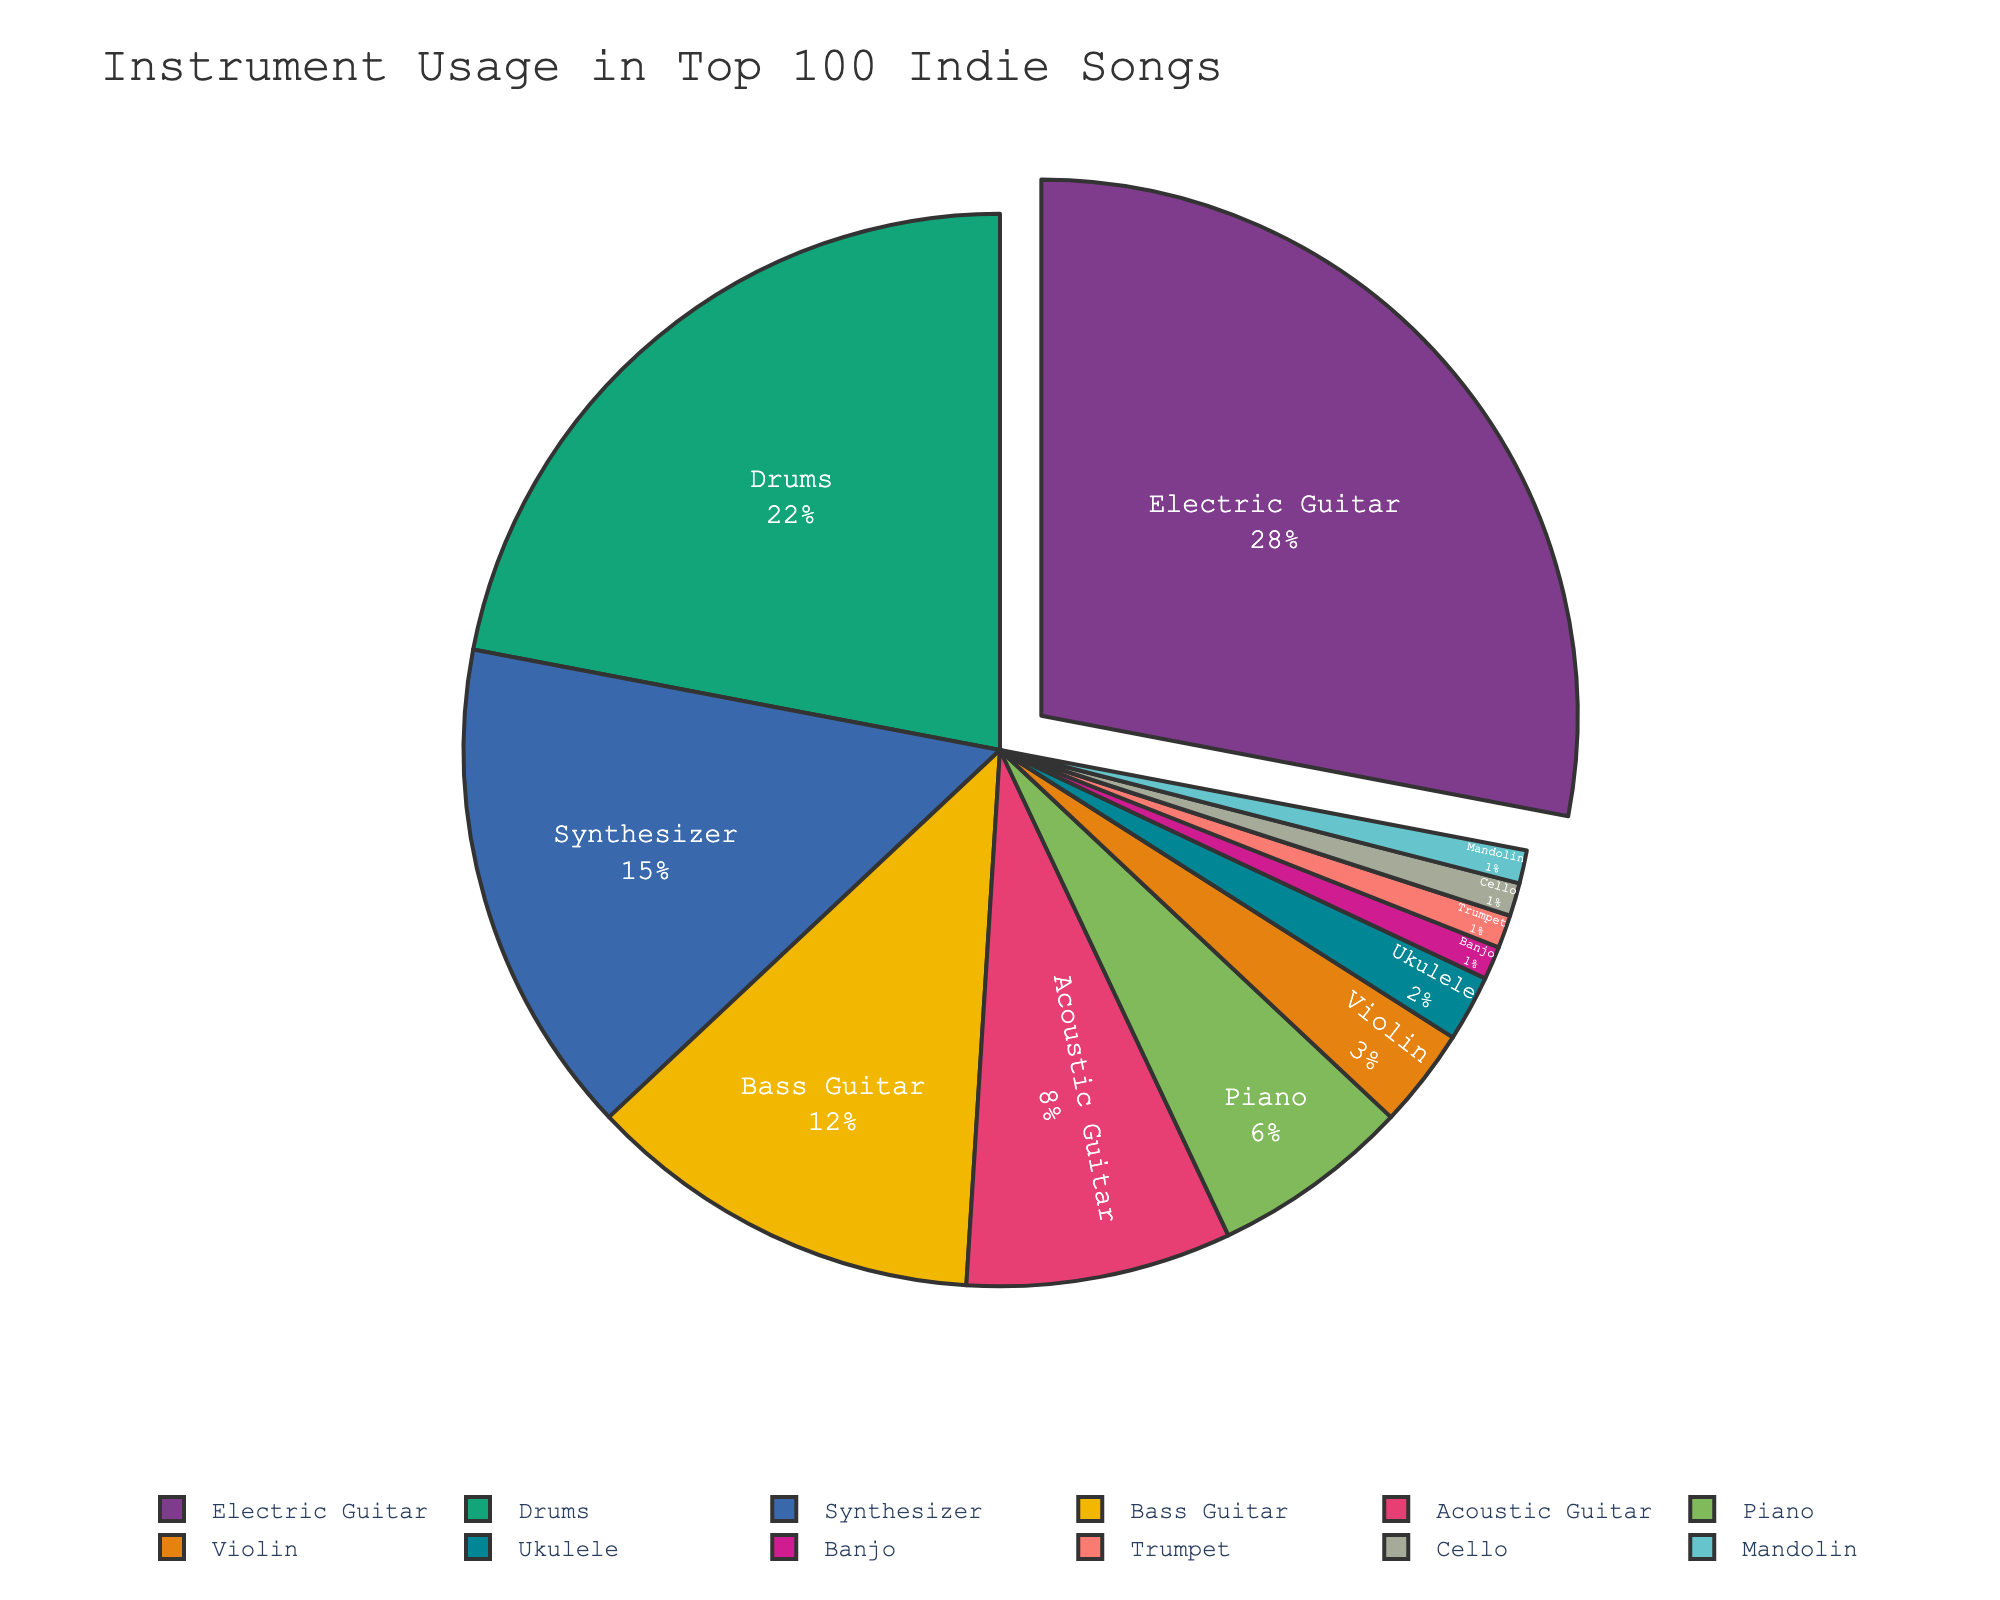Which instrument is the most used in the top 100 indie songs? The instrument with the highest percentage in the pie chart represents the most used instrument. The Electric Guitar shows the largest segment at 28%.
Answer: Electric Guitar Which two instruments have a combined usage percentage equal to that of Synthesizer? To find the instruments whose combined percentage equals the Synthesizer's 15%, we look for two segments that summing up to this value. Acoustic Guitar (8%) and Piano (6%) are close but not exact. Bass Guitar (12%) and Trumpet (1%) are still under; therefore, Ukulele (2%) and Violin (3%) combined equals 15%.
Answer: Acoustic Guitar and Piano How much more is the usage of Electric Guitar compared to Acoustic Guitar? Subtract the percentage of Acoustic Guitar from the percentage of Electric Guitar: 28% - 8% = 20%.
Answer: 20% Which instrument category has a usage nearly equal to one-third of Drums? Drums account for 22%. One-third of Drums would be approximately 7.3%. The closest segment to this value is Acoustic Guitar at 8%.
Answer: Acoustic Guitar Are there more songs featuring a Synthesizer or a Bass Guitar? Comparing the sizes of the Synthesizer and Bass Guitar segments shows that Synthesizer usage is 15% and Bass Guitar is 12%.
Answer: Synthesizer How many instruments have a usage percentage of 1%? Identify the instruments with 1% in the chart. There are four: Banjo, Trumpet, Cello, and Mandolin.
Answer: Four What's the least used instrument amongst the top 100 indie songs, tied with a specific number of instruments? The least used instruments would be those with the smallest percentage, which is 1% in this chart. Banjo, Trumpet, Cello, and Mandolin each have this percentage.
Answer: Banjo, Trumpet, Cello, and Mandolin Which instruments have more usage than Violin but less than Bass Guitar? Violin usage is 3% and Bass Guitar usage is 12%. Instruments that fall in between these values are Piano at 6% and Acoustic Guitar at 8%.
Answer: Piano and Acoustic Guitar 